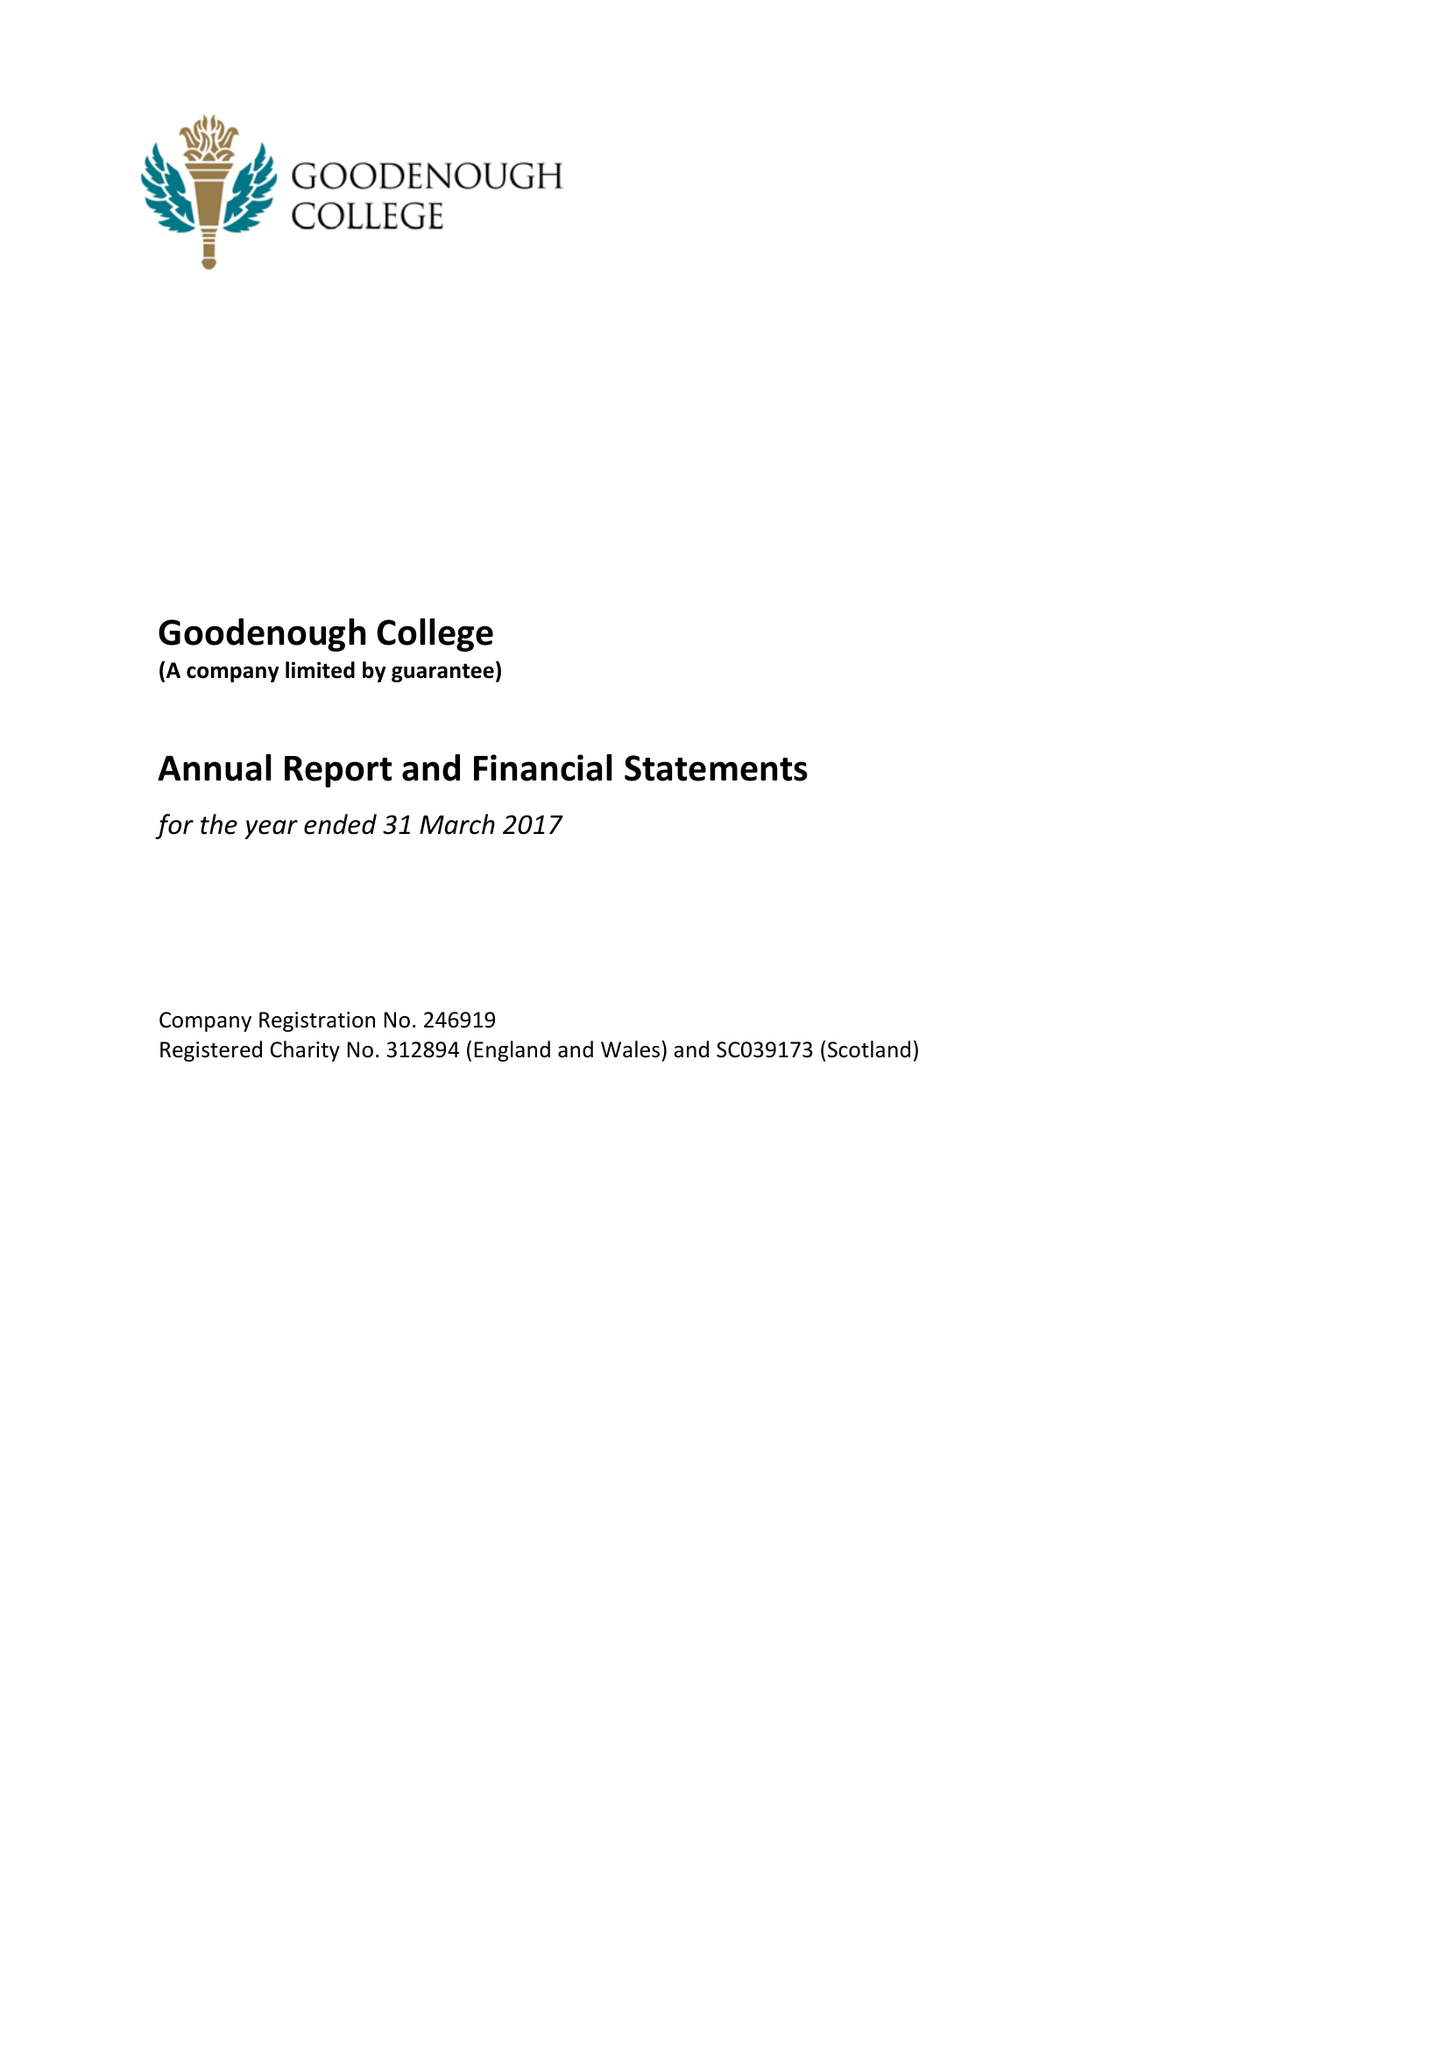What is the value for the charity_number?
Answer the question using a single word or phrase. 312894 